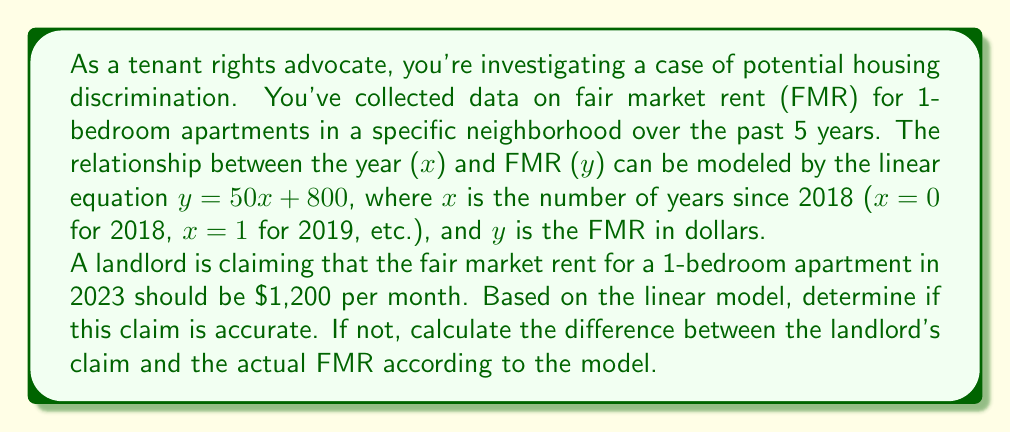Show me your answer to this math problem. To solve this problem, we need to follow these steps:

1. Identify the year we're interested in (2023) and determine its corresponding x-value.
2. Use the linear equation to calculate the FMR for 2023.
3. Compare the calculated FMR with the landlord's claim.
4. If there's a difference, calculate it.

Step 1: Determining the x-value for 2023
2023 is 5 years after 2018, so x = 5

Step 2: Calculating the FMR for 2023
Using the equation $y = 50x + 800$, we substitute x = 5:

$y = 50(5) + 800$
$y = 250 + 800$
$y = 1,050$

Therefore, the FMR for 2023 according to the model is $1,050.

Step 3: Comparing with the landlord's claim
The landlord claims the FMR should be $1,200, which is higher than the calculated FMR of $1,050.

Step 4: Calculating the difference
Difference = Landlord's claim - Calculated FMR
$1,200 - 1,050 = 150$

The landlord's claim is $150 higher than the FMR predicted by the linear model.
Answer: The landlord's claim is not accurate according to the linear model. The actual FMR for 2023 based on the model is $1,050, which is $150 less than the landlord's claim of $1,200. 